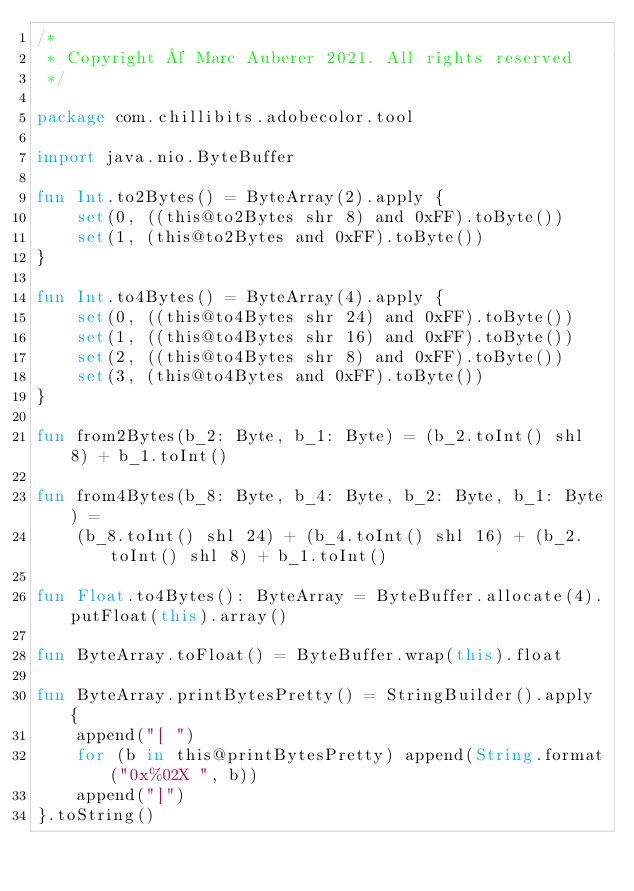Convert code to text. <code><loc_0><loc_0><loc_500><loc_500><_Kotlin_>/*
 * Copyright © Marc Auberer 2021. All rights reserved
 */

package com.chillibits.adobecolor.tool

import java.nio.ByteBuffer

fun Int.to2Bytes() = ByteArray(2).apply {
    set(0, ((this@to2Bytes shr 8) and 0xFF).toByte())
    set(1, (this@to2Bytes and 0xFF).toByte())
}

fun Int.to4Bytes() = ByteArray(4).apply {
    set(0, ((this@to4Bytes shr 24) and 0xFF).toByte())
    set(1, ((this@to4Bytes shr 16) and 0xFF).toByte())
    set(2, ((this@to4Bytes shr 8) and 0xFF).toByte())
    set(3, (this@to4Bytes and 0xFF).toByte())
}

fun from2Bytes(b_2: Byte, b_1: Byte) = (b_2.toInt() shl 8) + b_1.toInt()

fun from4Bytes(b_8: Byte, b_4: Byte, b_2: Byte, b_1: Byte) =
    (b_8.toInt() shl 24) + (b_4.toInt() shl 16) + (b_2.toInt() shl 8) + b_1.toInt()

fun Float.to4Bytes(): ByteArray = ByteBuffer.allocate(4).putFloat(this).array()

fun ByteArray.toFloat() = ByteBuffer.wrap(this).float

fun ByteArray.printBytesPretty() = StringBuilder().apply {
    append("[ ")
    for (b in this@printBytesPretty) append(String.format("0x%02X ", b))
    append("]")
}.toString()</code> 